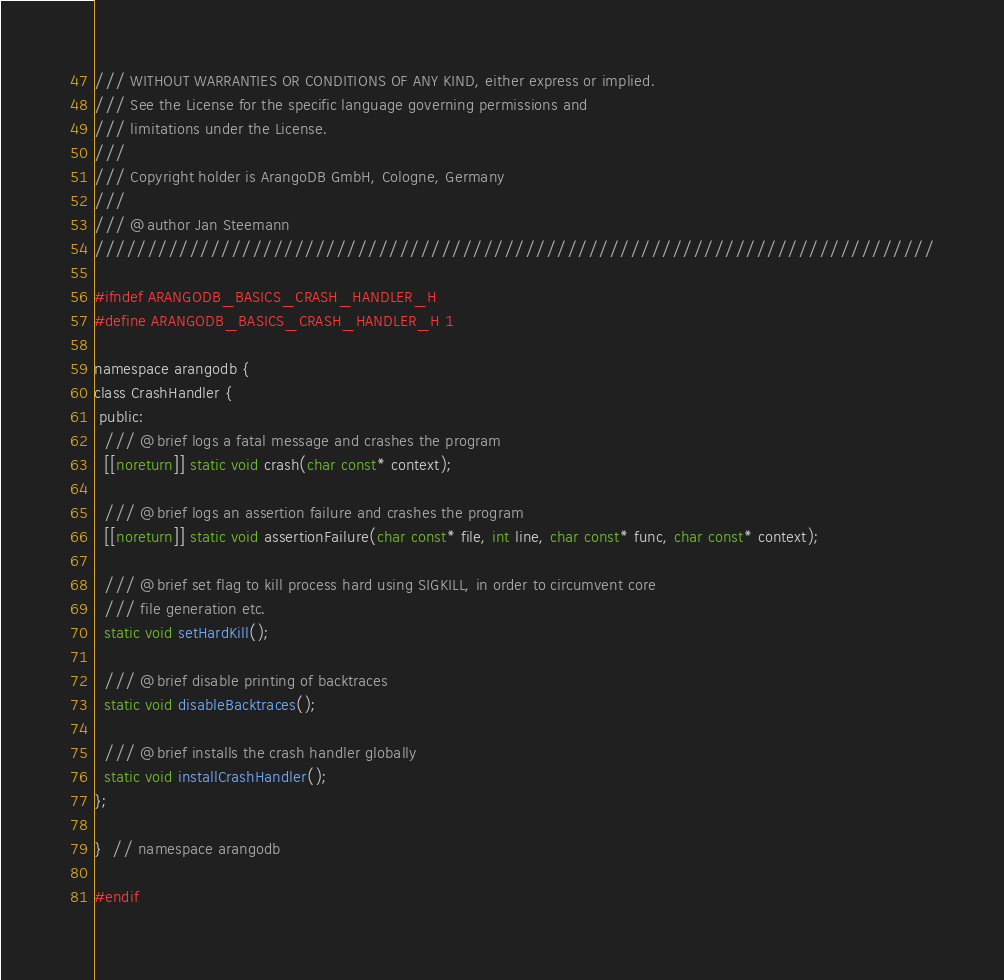Convert code to text. <code><loc_0><loc_0><loc_500><loc_500><_C_>/// WITHOUT WARRANTIES OR CONDITIONS OF ANY KIND, either express or implied.
/// See the License for the specific language governing permissions and
/// limitations under the License.
///
/// Copyright holder is ArangoDB GmbH, Cologne, Germany
///
/// @author Jan Steemann
////////////////////////////////////////////////////////////////////////////////

#ifndef ARANGODB_BASICS_CRASH_HANDLER_H
#define ARANGODB_BASICS_CRASH_HANDLER_H 1

namespace arangodb {
class CrashHandler {
 public:
  /// @brief logs a fatal message and crashes the program
  [[noreturn]] static void crash(char const* context);

  /// @brief logs an assertion failure and crashes the program
  [[noreturn]] static void assertionFailure(char const* file, int line, char const* func, char const* context);

  /// @brief set flag to kill process hard using SIGKILL, in order to circumvent core
  /// file generation etc.
  static void setHardKill();

  /// @brief disable printing of backtraces
  static void disableBacktraces();

  /// @brief installs the crash handler globally
  static void installCrashHandler();
};

}  // namespace arangodb

#endif
</code> 